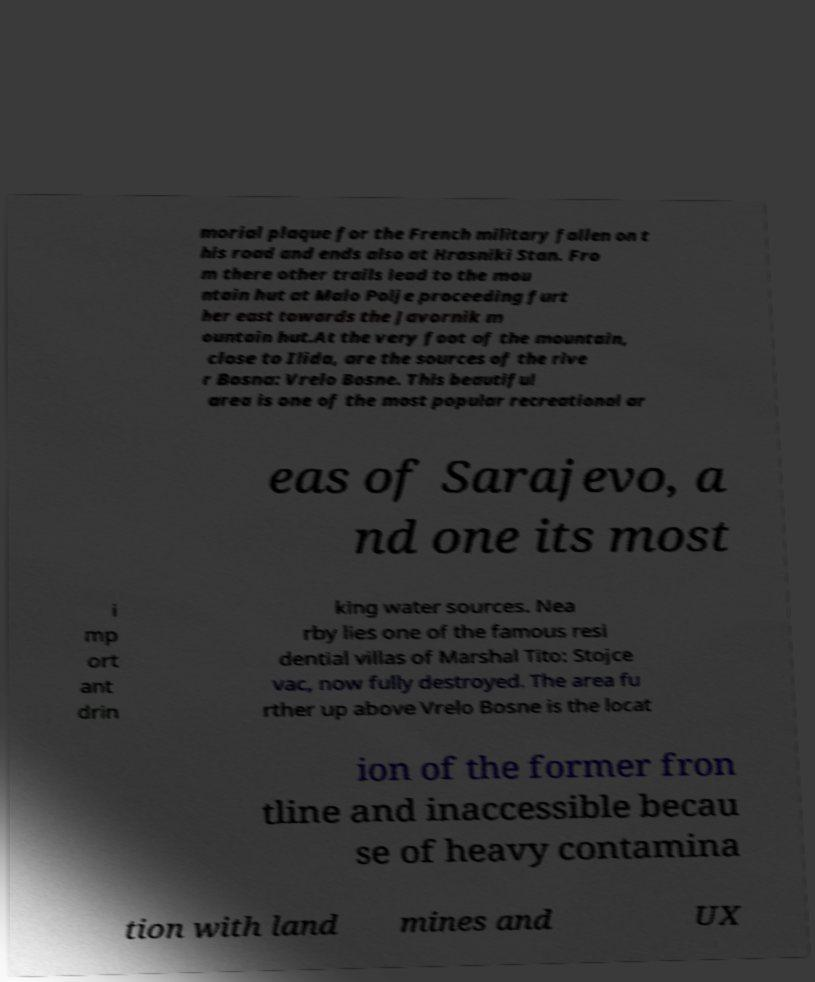Could you assist in decoding the text presented in this image and type it out clearly? morial plaque for the French military fallen on t his road and ends also at Hrasniki Stan. Fro m there other trails lead to the mou ntain hut at Malo Polje proceeding furt her east towards the Javornik m ountain hut.At the very foot of the mountain, close to Ilida, are the sources of the rive r Bosna: Vrelo Bosne. This beautiful area is one of the most popular recreational ar eas of Sarajevo, a nd one its most i mp ort ant drin king water sources. Nea rby lies one of the famous resi dential villas of Marshal Tito: Stojce vac, now fully destroyed. The area fu rther up above Vrelo Bosne is the locat ion of the former fron tline and inaccessible becau se of heavy contamina tion with land mines and UX 